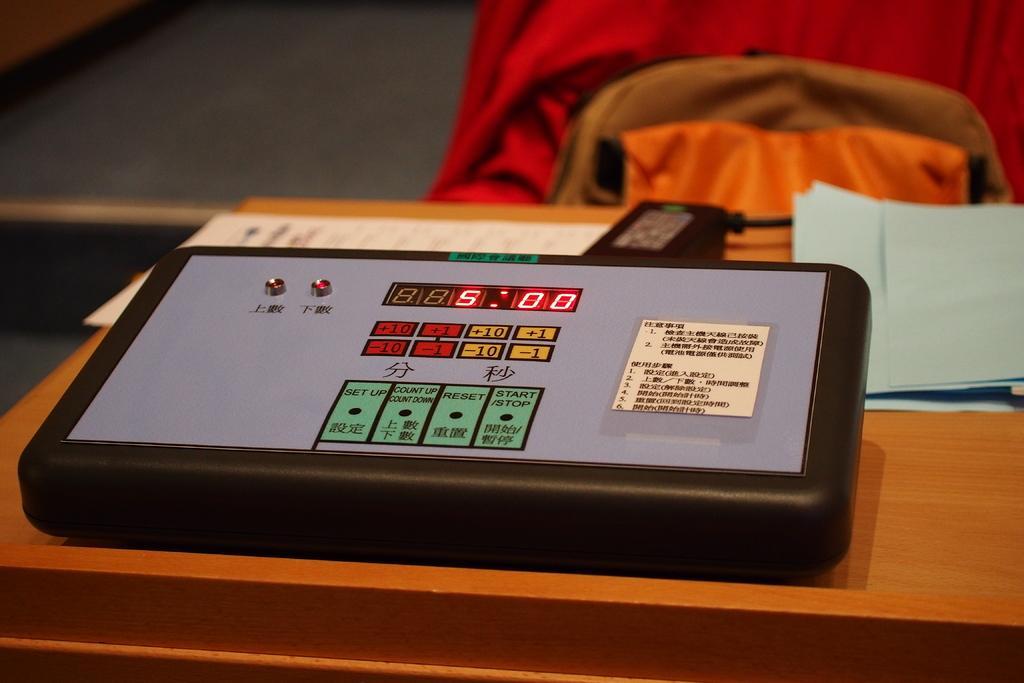Describe this image in one or two sentences. In this image there is an electronic machine on the table. Beside the machine there is a charger and there are papers on the right side. In the background there are clothes. 